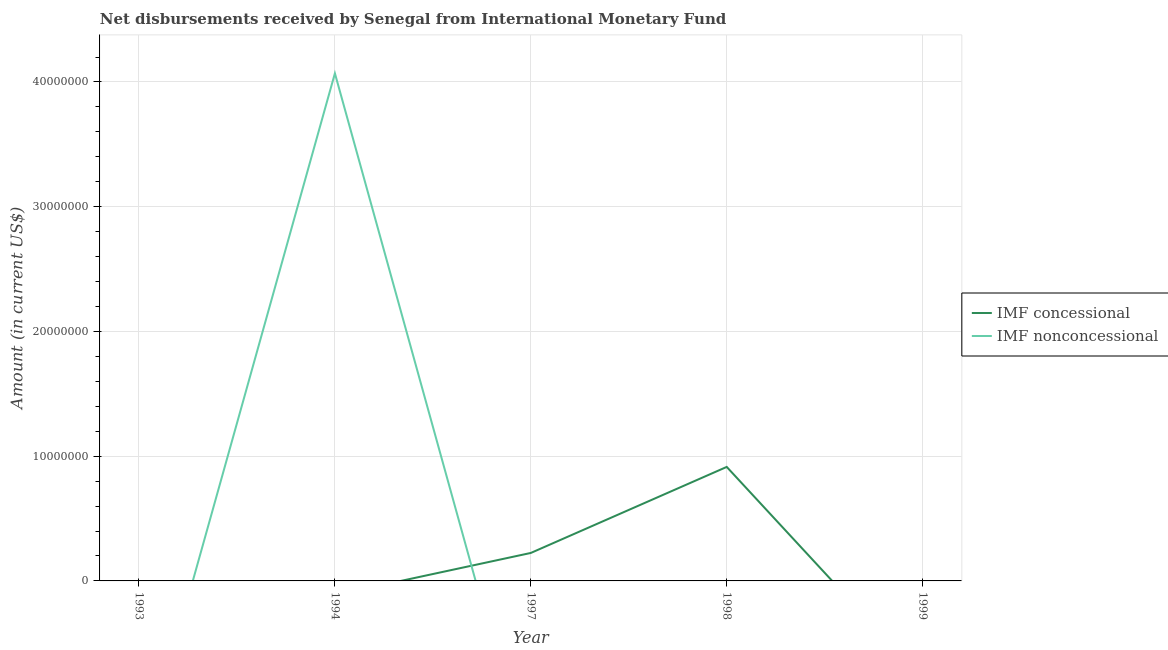Does the line corresponding to net non concessional disbursements from imf intersect with the line corresponding to net concessional disbursements from imf?
Provide a short and direct response. Yes. What is the net concessional disbursements from imf in 1994?
Keep it short and to the point. 0. Across all years, what is the maximum net non concessional disbursements from imf?
Offer a terse response. 4.07e+07. Across all years, what is the minimum net concessional disbursements from imf?
Make the answer very short. 0. In which year was the net concessional disbursements from imf maximum?
Your response must be concise. 1998. What is the total net non concessional disbursements from imf in the graph?
Make the answer very short. 4.07e+07. What is the difference between the net non concessional disbursements from imf in 1997 and the net concessional disbursements from imf in 1998?
Provide a succinct answer. -9.14e+06. What is the average net concessional disbursements from imf per year?
Keep it short and to the point. 2.28e+06. In how many years, is the net concessional disbursements from imf greater than 28000000 US$?
Your answer should be very brief. 0. What is the difference between the highest and the lowest net concessional disbursements from imf?
Your answer should be very brief. 9.14e+06. Does the net concessional disbursements from imf monotonically increase over the years?
Your response must be concise. No. Is the net concessional disbursements from imf strictly greater than the net non concessional disbursements from imf over the years?
Give a very brief answer. No. Is the net non concessional disbursements from imf strictly less than the net concessional disbursements from imf over the years?
Make the answer very short. No. How many years are there in the graph?
Your answer should be very brief. 5. Does the graph contain any zero values?
Your answer should be compact. Yes. Where does the legend appear in the graph?
Offer a terse response. Center right. How many legend labels are there?
Offer a very short reply. 2. What is the title of the graph?
Make the answer very short. Net disbursements received by Senegal from International Monetary Fund. What is the Amount (in current US$) in IMF concessional in 1994?
Keep it short and to the point. 0. What is the Amount (in current US$) in IMF nonconcessional in 1994?
Ensure brevity in your answer.  4.07e+07. What is the Amount (in current US$) of IMF concessional in 1997?
Provide a short and direct response. 2.24e+06. What is the Amount (in current US$) in IMF nonconcessional in 1997?
Keep it short and to the point. 0. What is the Amount (in current US$) in IMF concessional in 1998?
Keep it short and to the point. 9.14e+06. What is the Amount (in current US$) of IMF nonconcessional in 1998?
Ensure brevity in your answer.  0. What is the Amount (in current US$) in IMF concessional in 1999?
Ensure brevity in your answer.  0. Across all years, what is the maximum Amount (in current US$) in IMF concessional?
Offer a very short reply. 9.14e+06. Across all years, what is the maximum Amount (in current US$) of IMF nonconcessional?
Ensure brevity in your answer.  4.07e+07. What is the total Amount (in current US$) in IMF concessional in the graph?
Give a very brief answer. 1.14e+07. What is the total Amount (in current US$) of IMF nonconcessional in the graph?
Provide a short and direct response. 4.07e+07. What is the difference between the Amount (in current US$) of IMF concessional in 1997 and that in 1998?
Ensure brevity in your answer.  -6.90e+06. What is the average Amount (in current US$) of IMF concessional per year?
Your answer should be compact. 2.28e+06. What is the average Amount (in current US$) of IMF nonconcessional per year?
Give a very brief answer. 8.14e+06. What is the ratio of the Amount (in current US$) of IMF concessional in 1997 to that in 1998?
Your answer should be very brief. 0.25. What is the difference between the highest and the lowest Amount (in current US$) of IMF concessional?
Offer a very short reply. 9.14e+06. What is the difference between the highest and the lowest Amount (in current US$) of IMF nonconcessional?
Give a very brief answer. 4.07e+07. 